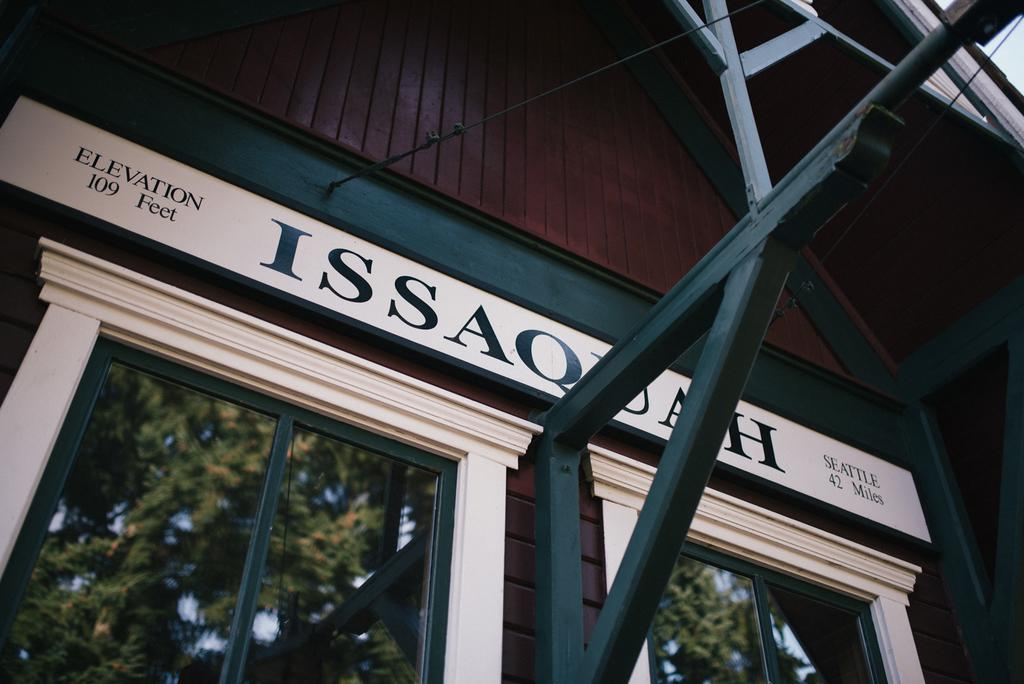What is the main structure in the image? There is a building in the image. What feature can be seen on the building? There are windows on the building. What can be seen in the reflection of the windows? The windows have a reflection of trees. What else is visible in the image besides the building and trees? There is text visible in the image. Can you tell me how many pets are visible in the image? There are no pets present in the image. What type of agreement is being signed in the image? There is no agreement or signing activity depicted in the image. 